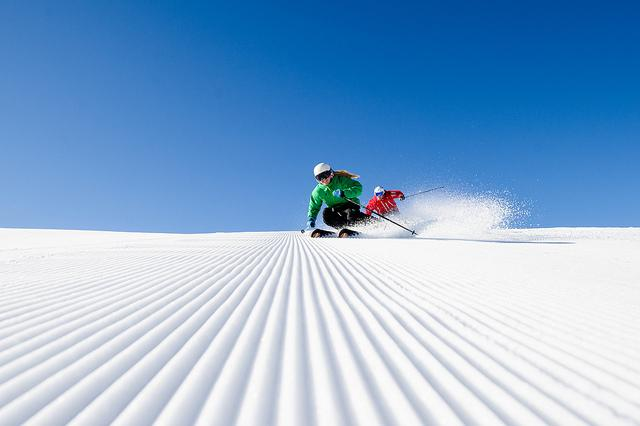The person in the lead is wearing what color jacket?

Choices:
A) blue
B) yellow
C) green
D) black green 